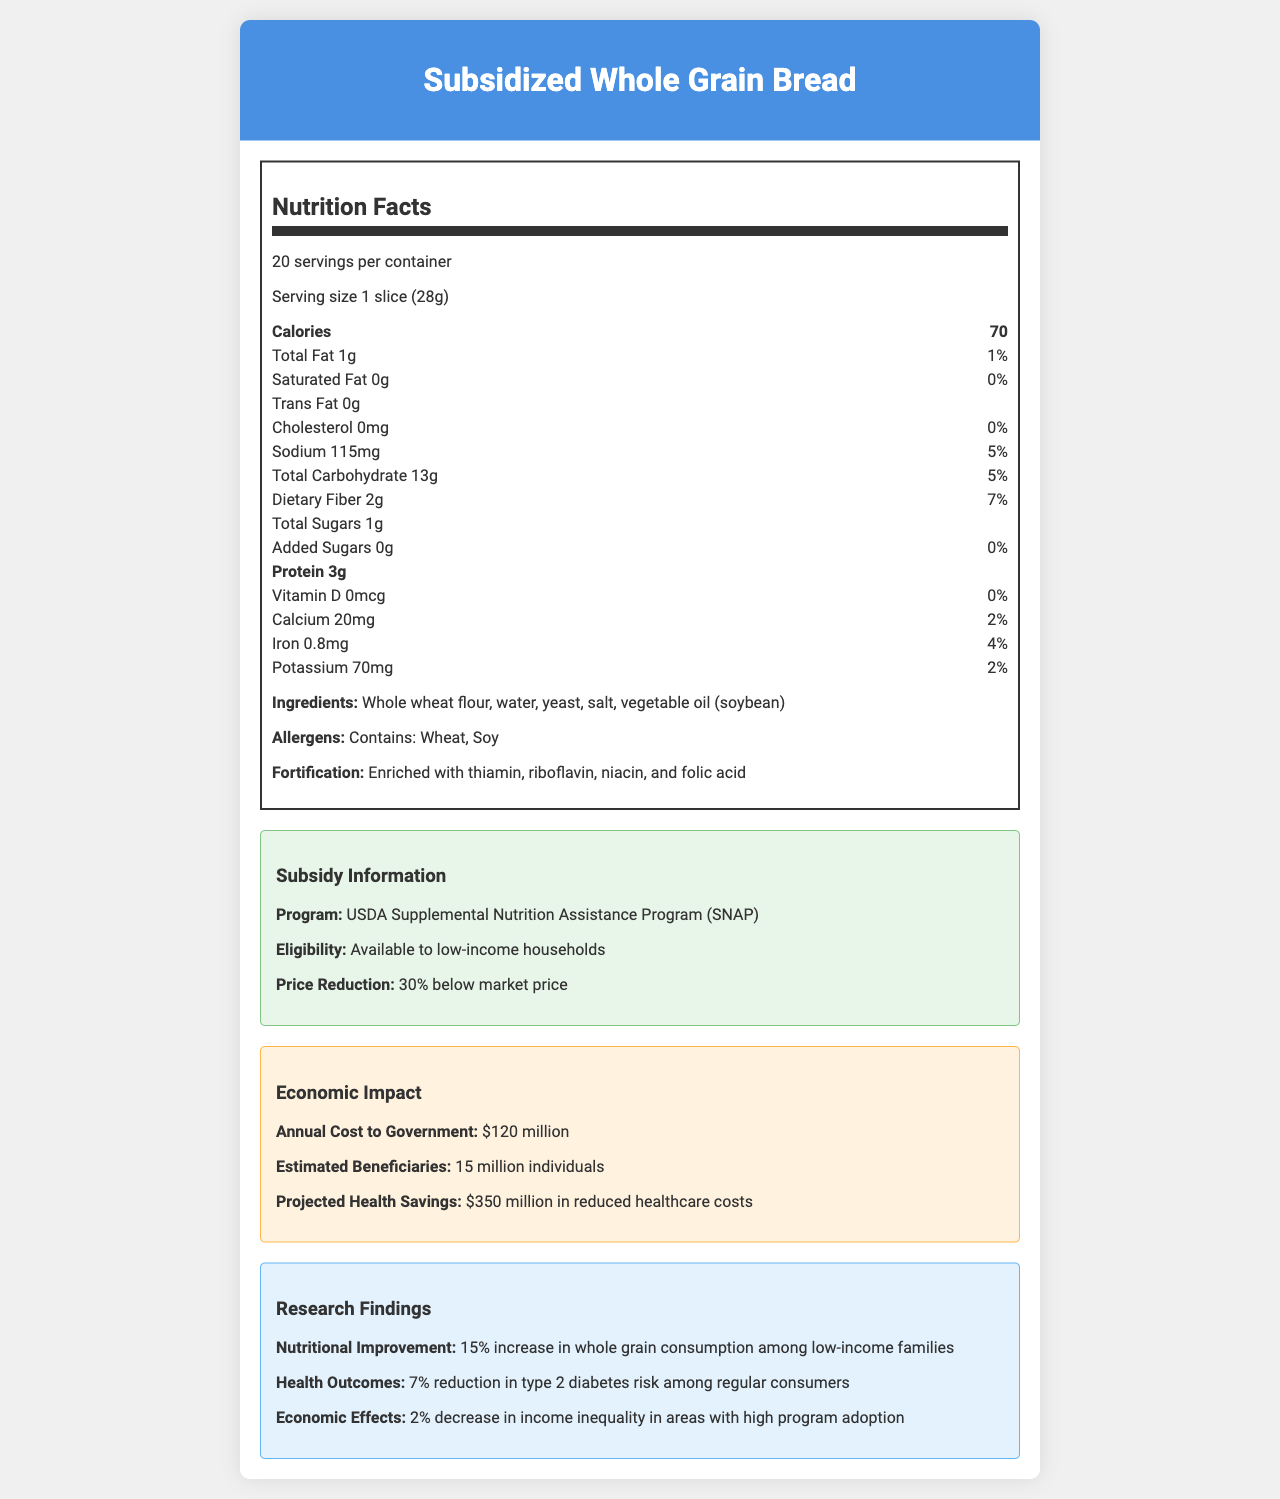what is the product name? The product name is given at the top of the document.
Answer: Subsidized Whole Grain Bread what is the serving size? The serving size is specified in the nutrition facts section.
Answer: 1 slice (28g) how many calories are in one serving? The calorie count is listed in the nutrition facts.
Answer: 70 what are the main ingredients? The main ingredients are listed under the ingredients section.
Answer: Whole wheat flour, water, yeast, salt, vegetable oil (soybean) how much dietary fiber is in one serving? The dietary fiber content is provided in the nutrition facts under "Total Carbohydrate".
Answer: 2g what is the daily value percentage for sodium? The document lists the daily value percentages for various nutrients, including sodium.
Answer: 5% does the bread contain trans fat? The nutrition label indicates there is 0g of trans fat.
Answer: No what program subsidizes this food item? The subsidy information section specifies the program.
Answer: USDA Supplemental Nutrition Assistance Program (SNAP) did the government apply fortification to this bread? The document mentions that the bread is enriched with thiamin, riboflavin, niacin, and folic acid.
Answer: Yes how many servings are there per container? The number of servings per container is listed near the top of the nutrition facts label.
Answer: 20 what is the projected health savings from reduced healthcare costs? The economic impact section outlines the projected health savings.
Answer: $350 million which vitamin is not present in the bread? I. Vitamin A II. Vitamin D III. Vitamin C The nutrition facts section indicates that there is 0mcg of Vitamin D.
Answer: II. Vitamin D is this bread suitable for someone with a soy allergy? The allergen section states that the bread contains soy.
Answer: No what is the economic impact of the subsidy program? The economic impact includes both costs and benefits as specified in the economic impact section.
Answer: The government incurs an annual cost of $120 million, with an estimated 15 million beneficiaries and projected health savings of $350 million in reduced healthcare costs. what are the sustainability notes related to the packaging? The document mentions the sustainability notes, stating the packaging is made partially from recycled materials.
Answer: Packaging made from 30% recycled materials what is the amount of potassium in one serving? The potassium content is listed in the nutrition facts.
Answer: 70mg does the total sugar content in the bread include added sugars? The total sugars amount is 1g, and the document specifies that added sugars amount to 0g.
Answer: No how does the bread impact whole grain consumption among low-income families? The research findings state a 15% increase in whole grain consumption among low-income families.
Answer: 15% increase how does the bread affect type 2 diabetes risk? The health outcomes section states a 7% reduction in type 2 diabetes risk among regular consumers.
Answer: 7% reduction what is the amount of iron per serving? The nutrition facts section lists the amount of iron per serving.
Answer: 0.8mg what does the subsidy information reveal about the eligibility of the program? The subsidy information section states the eligibility criteria for the SNAP program.
Answer: Available to low-income households what is the main idea of the document? The document includes details about the product’s nutritional content, subsidy program under USDA SNAP, economic costs and benefits, distribution channels, sustainability, and the positive impact on nutrition and health.
Answer: The document showcases the nutritional value, subsidy information, economic impact, and research findings related to Subsidized Whole Grain Bread, highlighting its accessibility and health benefits for low-income households. what year did the subsidy program start? The document does not provide information on the start year of the subsidy program.
Answer: Not enough information 